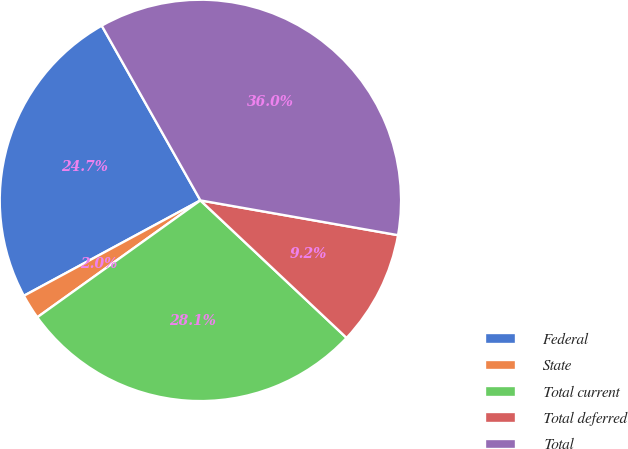Convert chart to OTSL. <chart><loc_0><loc_0><loc_500><loc_500><pie_chart><fcel>Federal<fcel>State<fcel>Total current<fcel>Total deferred<fcel>Total<nl><fcel>24.7%<fcel>2.01%<fcel>28.09%<fcel>9.24%<fcel>35.95%<nl></chart> 